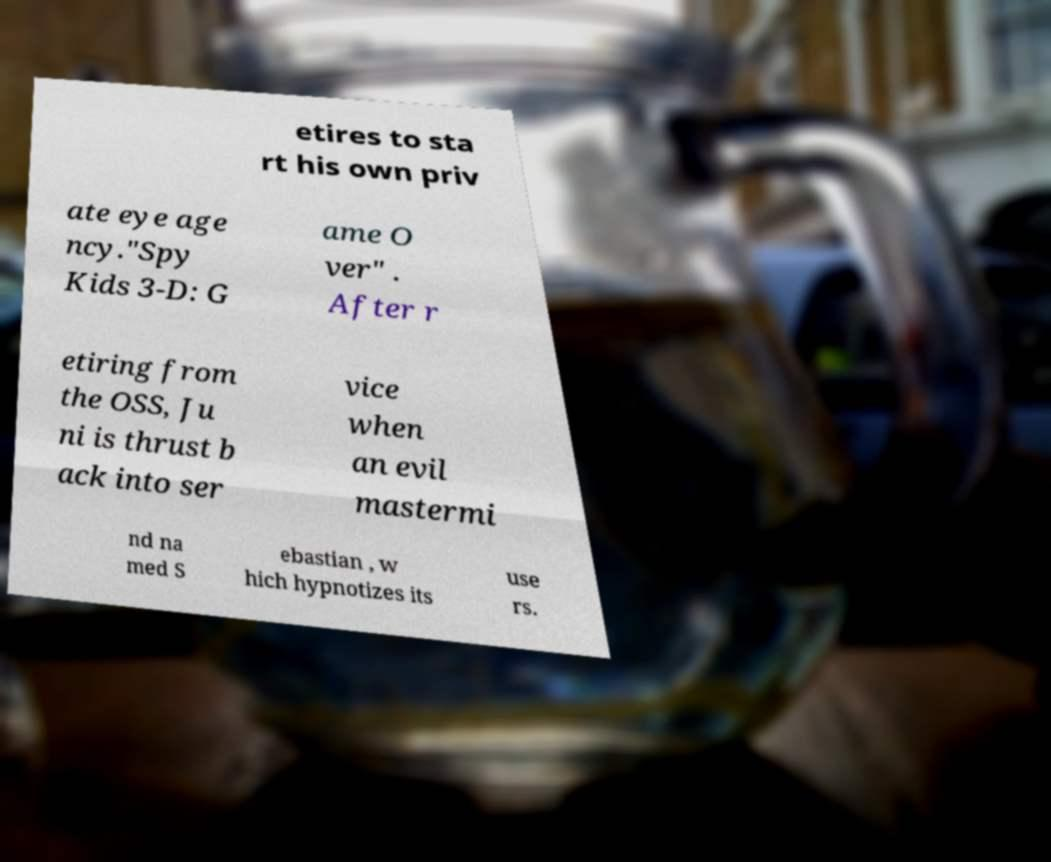For documentation purposes, I need the text within this image transcribed. Could you provide that? etires to sta rt his own priv ate eye age ncy."Spy Kids 3-D: G ame O ver" . After r etiring from the OSS, Ju ni is thrust b ack into ser vice when an evil mastermi nd na med S ebastian , w hich hypnotizes its use rs. 